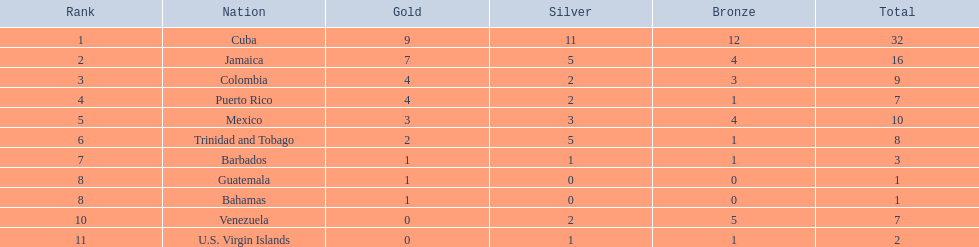Which 3 nations received the most medals? Cuba, Jamaica, Colombia. Of these 3 nations, which ones are islands? Cuba, Jamaica. Which one obtained the most silver medals? Cuba. 